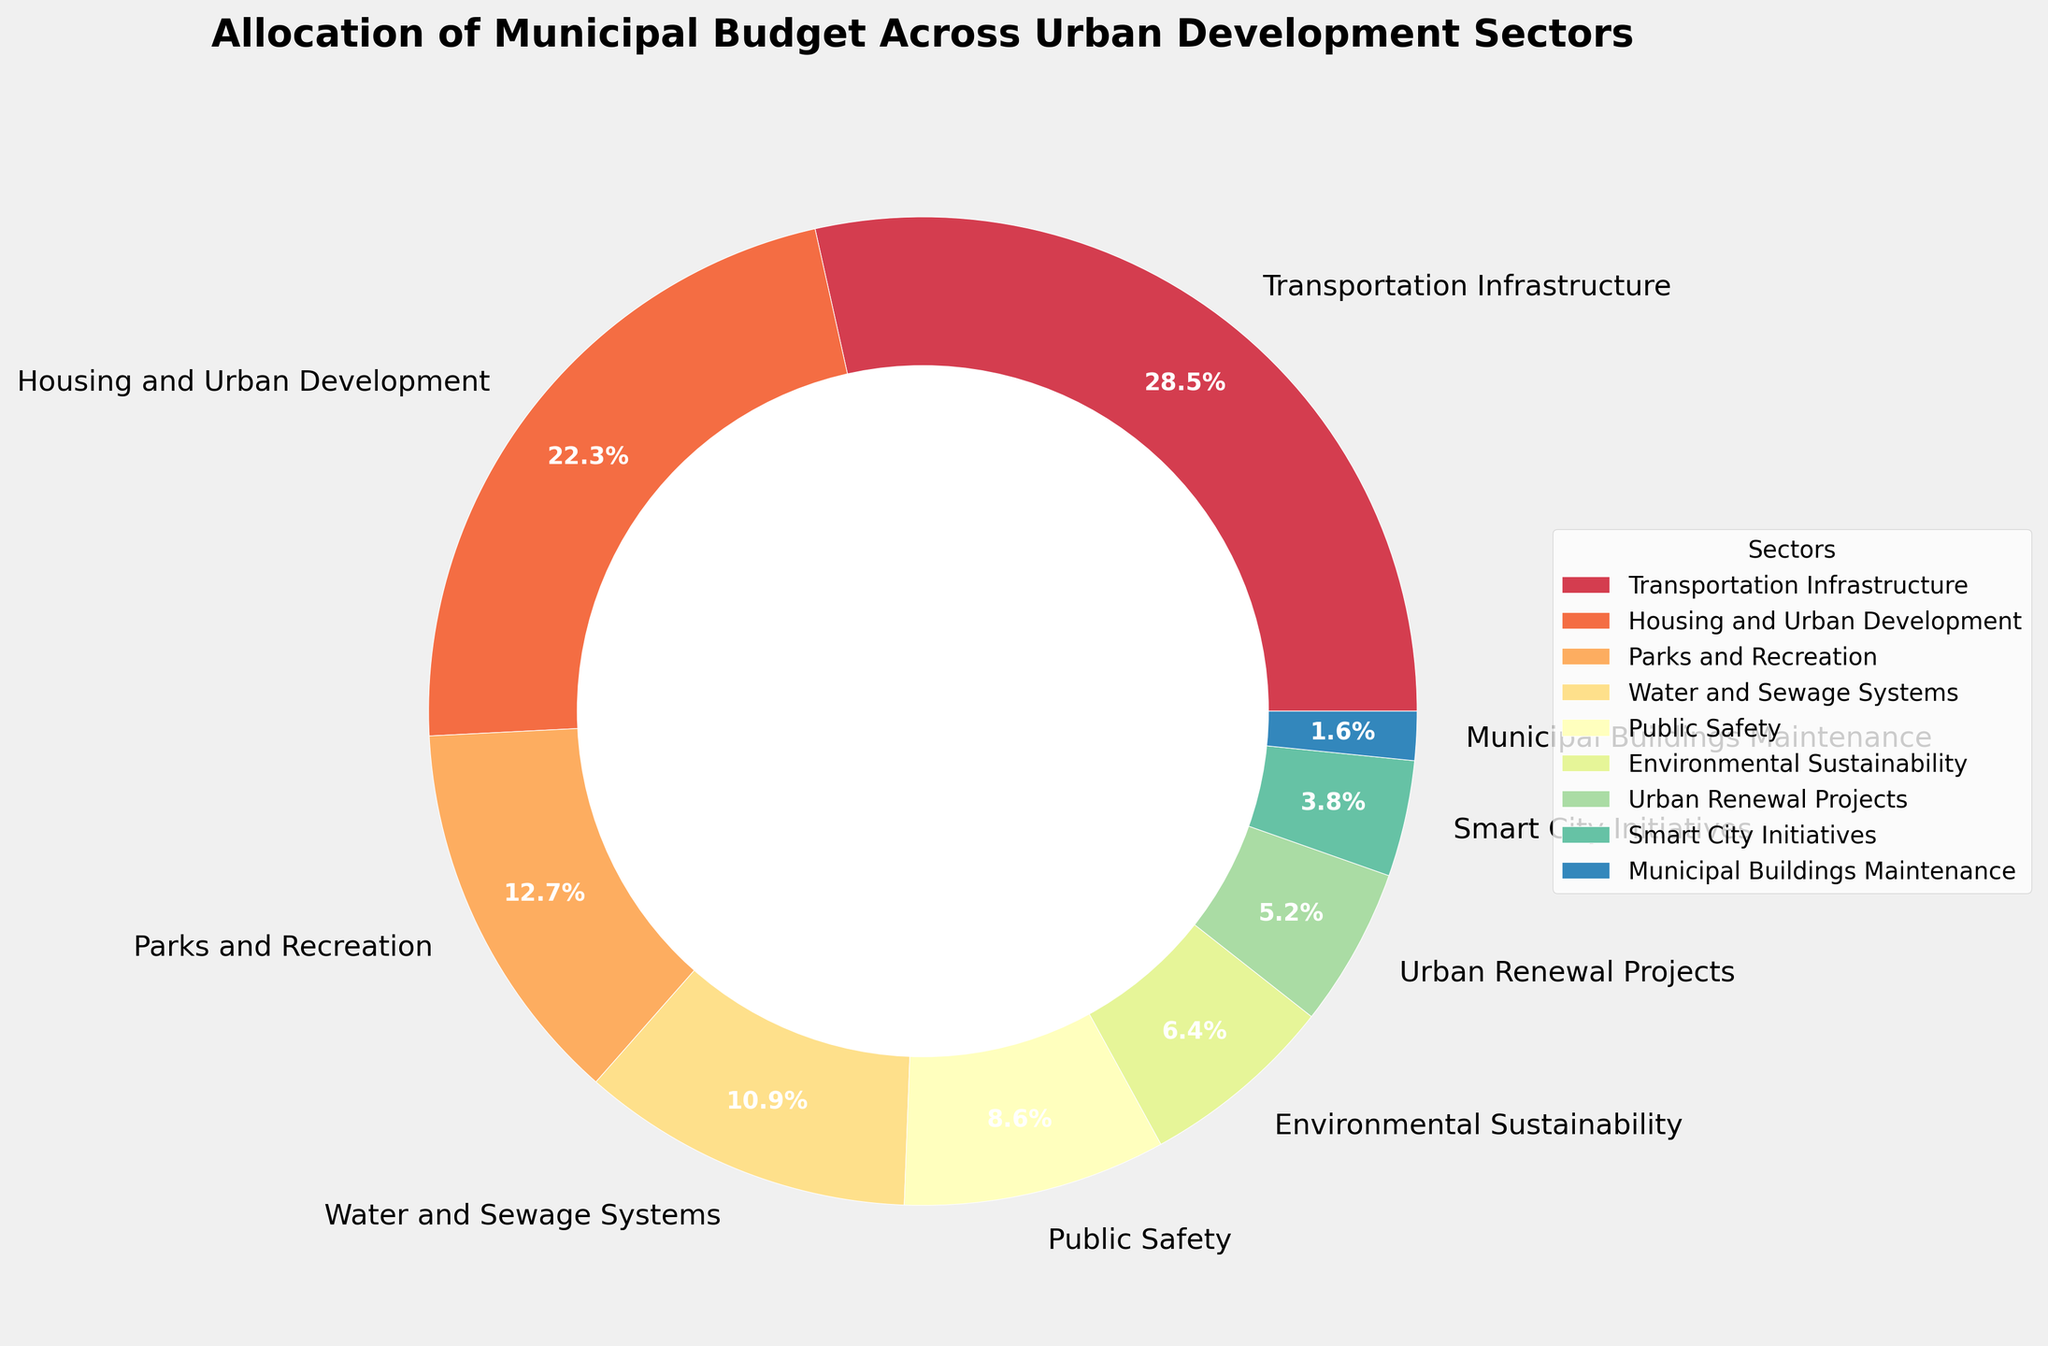Which sector received the highest budget allocation? Look at the sectors and their corresponding percentages in the pie chart. Identify the sector with the largest percentage.
Answer: Transportation Infrastructure Which sector had a budget allocation of less than 5%? Scan the chart for sectors with a percentage less than 5%. Identify the sectors that meet this criterion.
Answer: Smart City Initiatives, Municipal Buildings Maintenance What is the total budget allocation for Parks and Recreation combined with Environmental Sustainability? Add the percentage of Parks and Recreation (12.7%) and Environmental Sustainability (6.4%).
Answer: 19.1% How does the budget allocation for Public Safety compare to Housing and Urban Development? Compare the percentages of Public Safety (8.6%) and Housing and Urban Development (22.3%). Determine which is greater and by how much.
Answer: Housing and Urban Development is greater by 13.7% Which sector is allocated more budget: Urban Renewal Projects or Smart City Initiatives? Compare the percentages of Urban Renewal Projects (5.2%) and Smart City Initiatives (3.8%). Identify which sector has a higher allocation.
Answer: Urban Renewal Projects What's the average budget allocation percentage for Water and Sewage Systems, Public Safety, and Environmental Sustainability? Add the percentages of Water and Sewage Systems (10.9%), Public Safety (8.6%), and Environmental Sustainability (6.4%) and then divide by 3.
Answer: 8.63% Is the allocation for Parks and Recreation higher than that for Water and Sewage Systems? Compare the percentage for Parks and Recreation (12.7%) with that for Water and Sewage Systems (10.9%).
Answer: Yes What's the difference in budget allocation between Transportation Infrastructure and Municipal Buildings Maintenance? Subtract the percentage of Municipal Buildings Maintenance (1.6%) from Transportation Infrastructure (28.5%).
Answer: 26.9% If we combine the budget allocations for Smart City Initiatives and Municipal Buildings Maintenance, what is the total percentage? Add the percentages for Smart City Initiatives (3.8%) and Municipal Buildings Maintenance (1.6%).
Answer: 5.4% Which sector with budget allocation between 5% to 10% is depicted in the chart? Identify sectors with budget allocations in the specified range by checking their percentages.
Answer: Urban Renewal Projects 